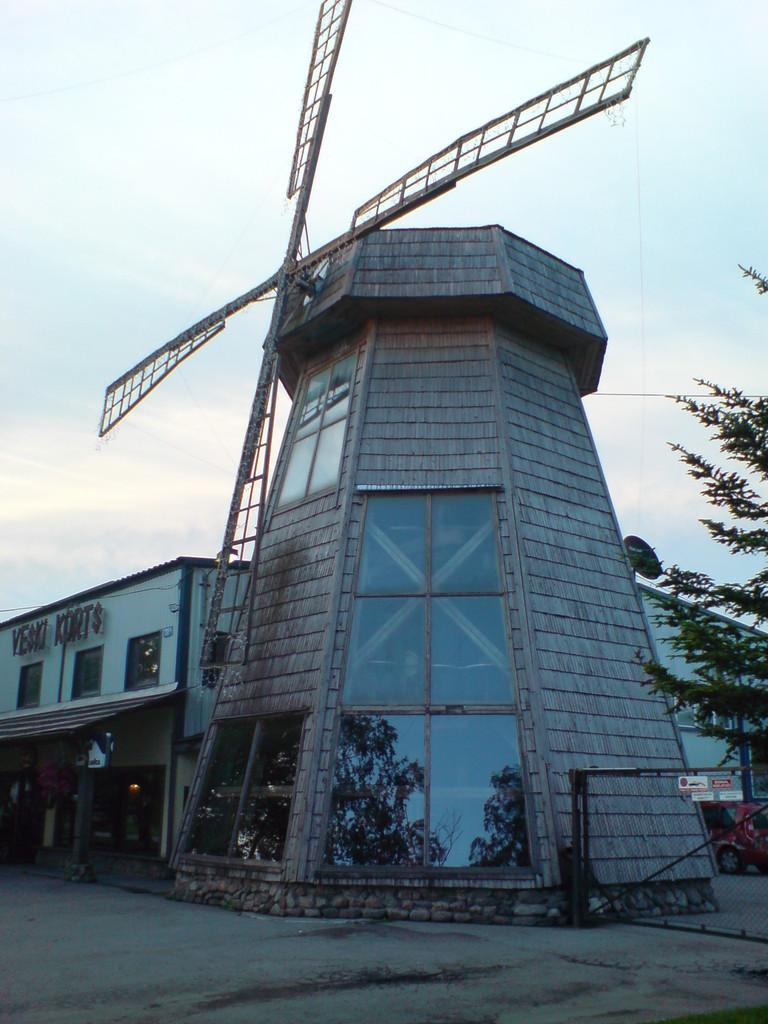What is the main structure in the image? There is a windmill in the image. What other natural elements can be seen in the image? There is a tree in the image. Are there any man-made structures visible? Yes, there is a building in the image. What can be seen in the background of the image? There are clouds and the sky visible in the background of the image. Is there any text or writing present in the image? Yes, there is text or writing present in the image. What type of curtain can be seen hanging from the windmill in the image? There is no curtain present in the image, as it features a windmill, a tree, a building, clouds, the sky, and text or writing. 